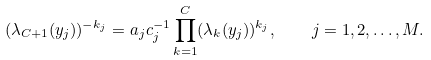Convert formula to latex. <formula><loc_0><loc_0><loc_500><loc_500>( \lambda _ { C + 1 } ( y _ { j } ) ) ^ { - k _ { j } } = a _ { j } c _ { j } ^ { - 1 } \prod _ { k = 1 } ^ { C } ( \lambda _ { k } ( y _ { j } ) ) ^ { k _ { j } } , \quad j = 1 , 2 , \dots , M .</formula> 